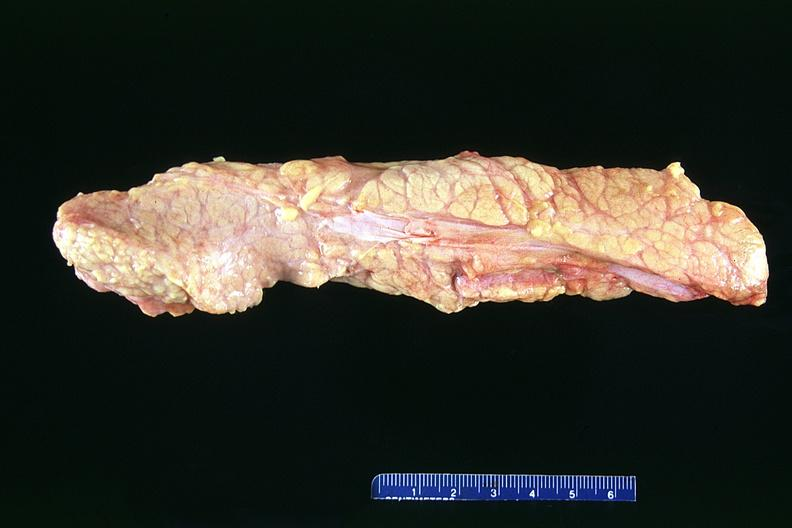what does this image show?
Answer the question using a single word or phrase. Normal pancreas 